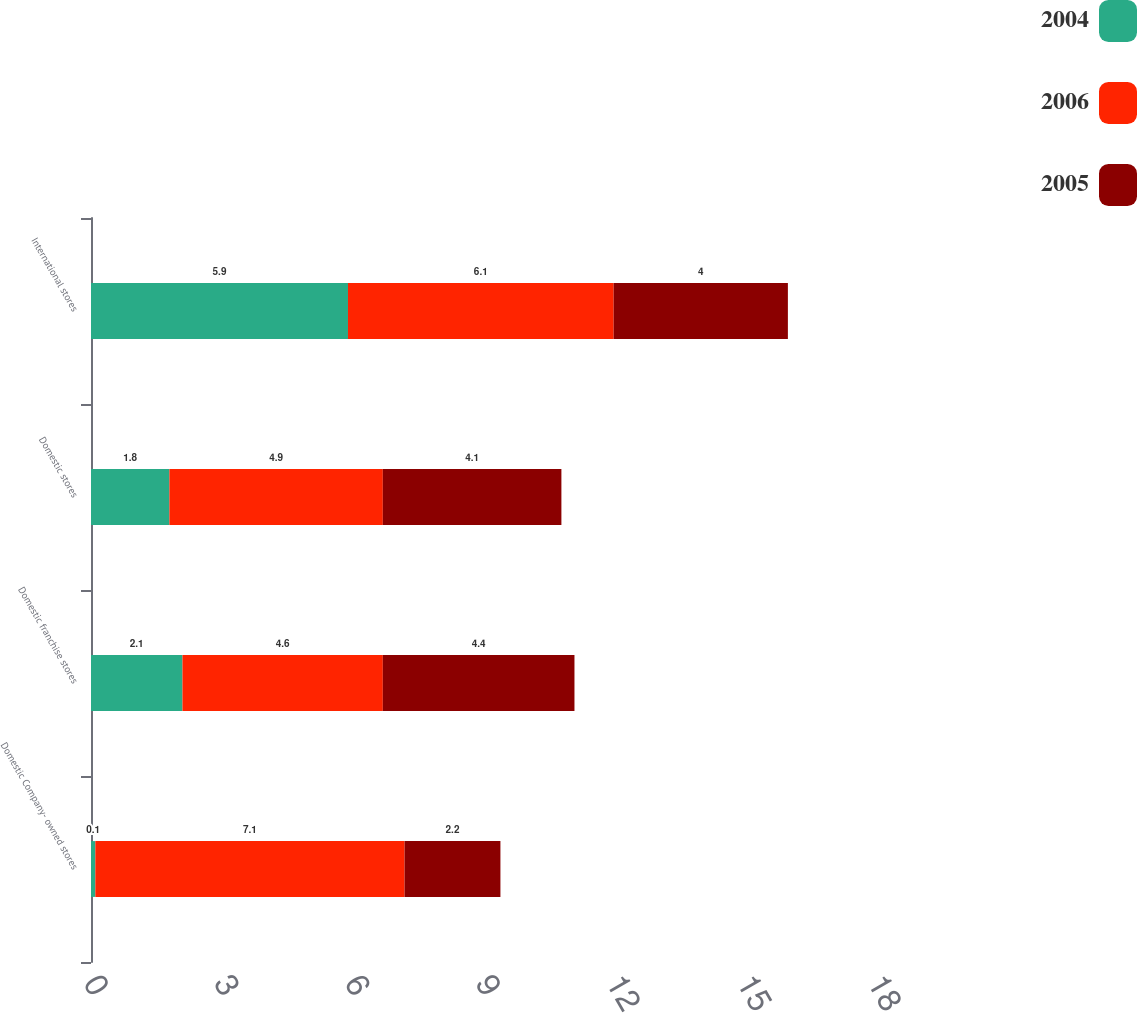Convert chart. <chart><loc_0><loc_0><loc_500><loc_500><stacked_bar_chart><ecel><fcel>Domestic Company- owned stores<fcel>Domestic franchise stores<fcel>Domestic stores<fcel>International stores<nl><fcel>2004<fcel>0.1<fcel>2.1<fcel>1.8<fcel>5.9<nl><fcel>2006<fcel>7.1<fcel>4.6<fcel>4.9<fcel>6.1<nl><fcel>2005<fcel>2.2<fcel>4.4<fcel>4.1<fcel>4<nl></chart> 